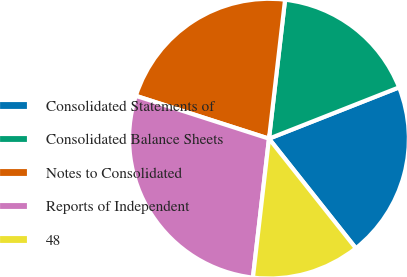Convert chart. <chart><loc_0><loc_0><loc_500><loc_500><pie_chart><fcel>Consolidated Statements of<fcel>Consolidated Balance Sheets<fcel>Notes to Consolidated<fcel>Reports of Independent<fcel>48<nl><fcel>20.31%<fcel>17.19%<fcel>21.88%<fcel>28.12%<fcel>12.5%<nl></chart> 